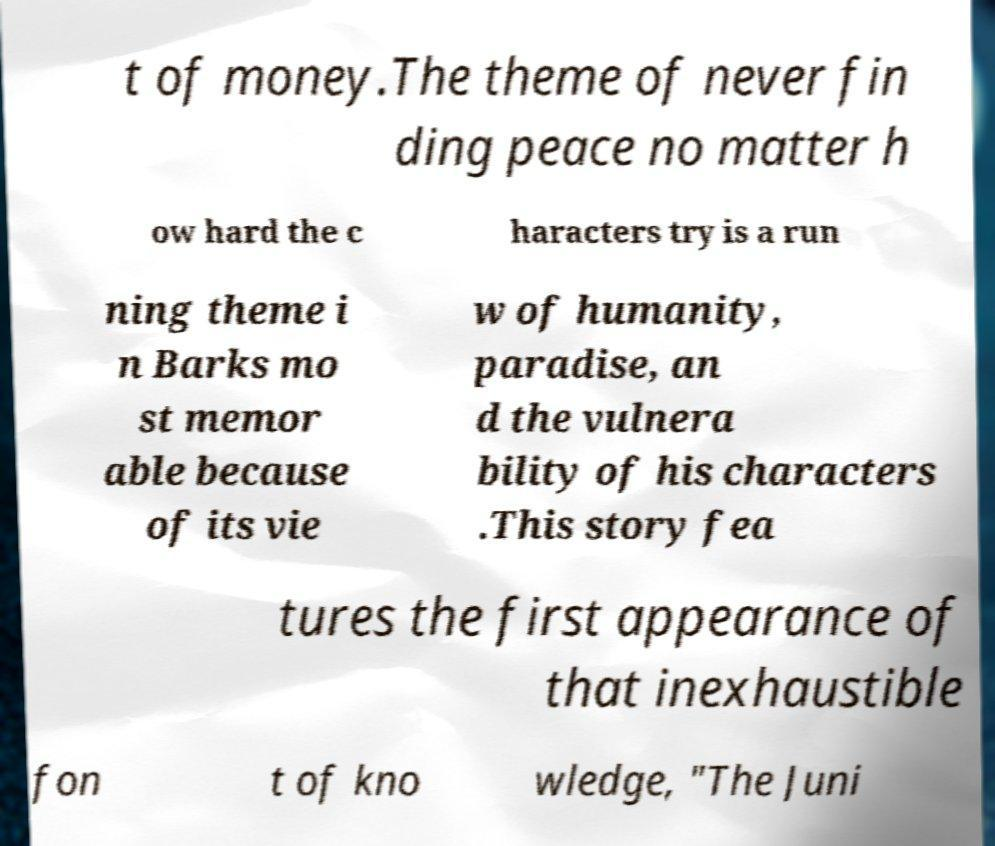There's text embedded in this image that I need extracted. Can you transcribe it verbatim? t of money.The theme of never fin ding peace no matter h ow hard the c haracters try is a run ning theme i n Barks mo st memor able because of its vie w of humanity, paradise, an d the vulnera bility of his characters .This story fea tures the first appearance of that inexhaustible fon t of kno wledge, "The Juni 